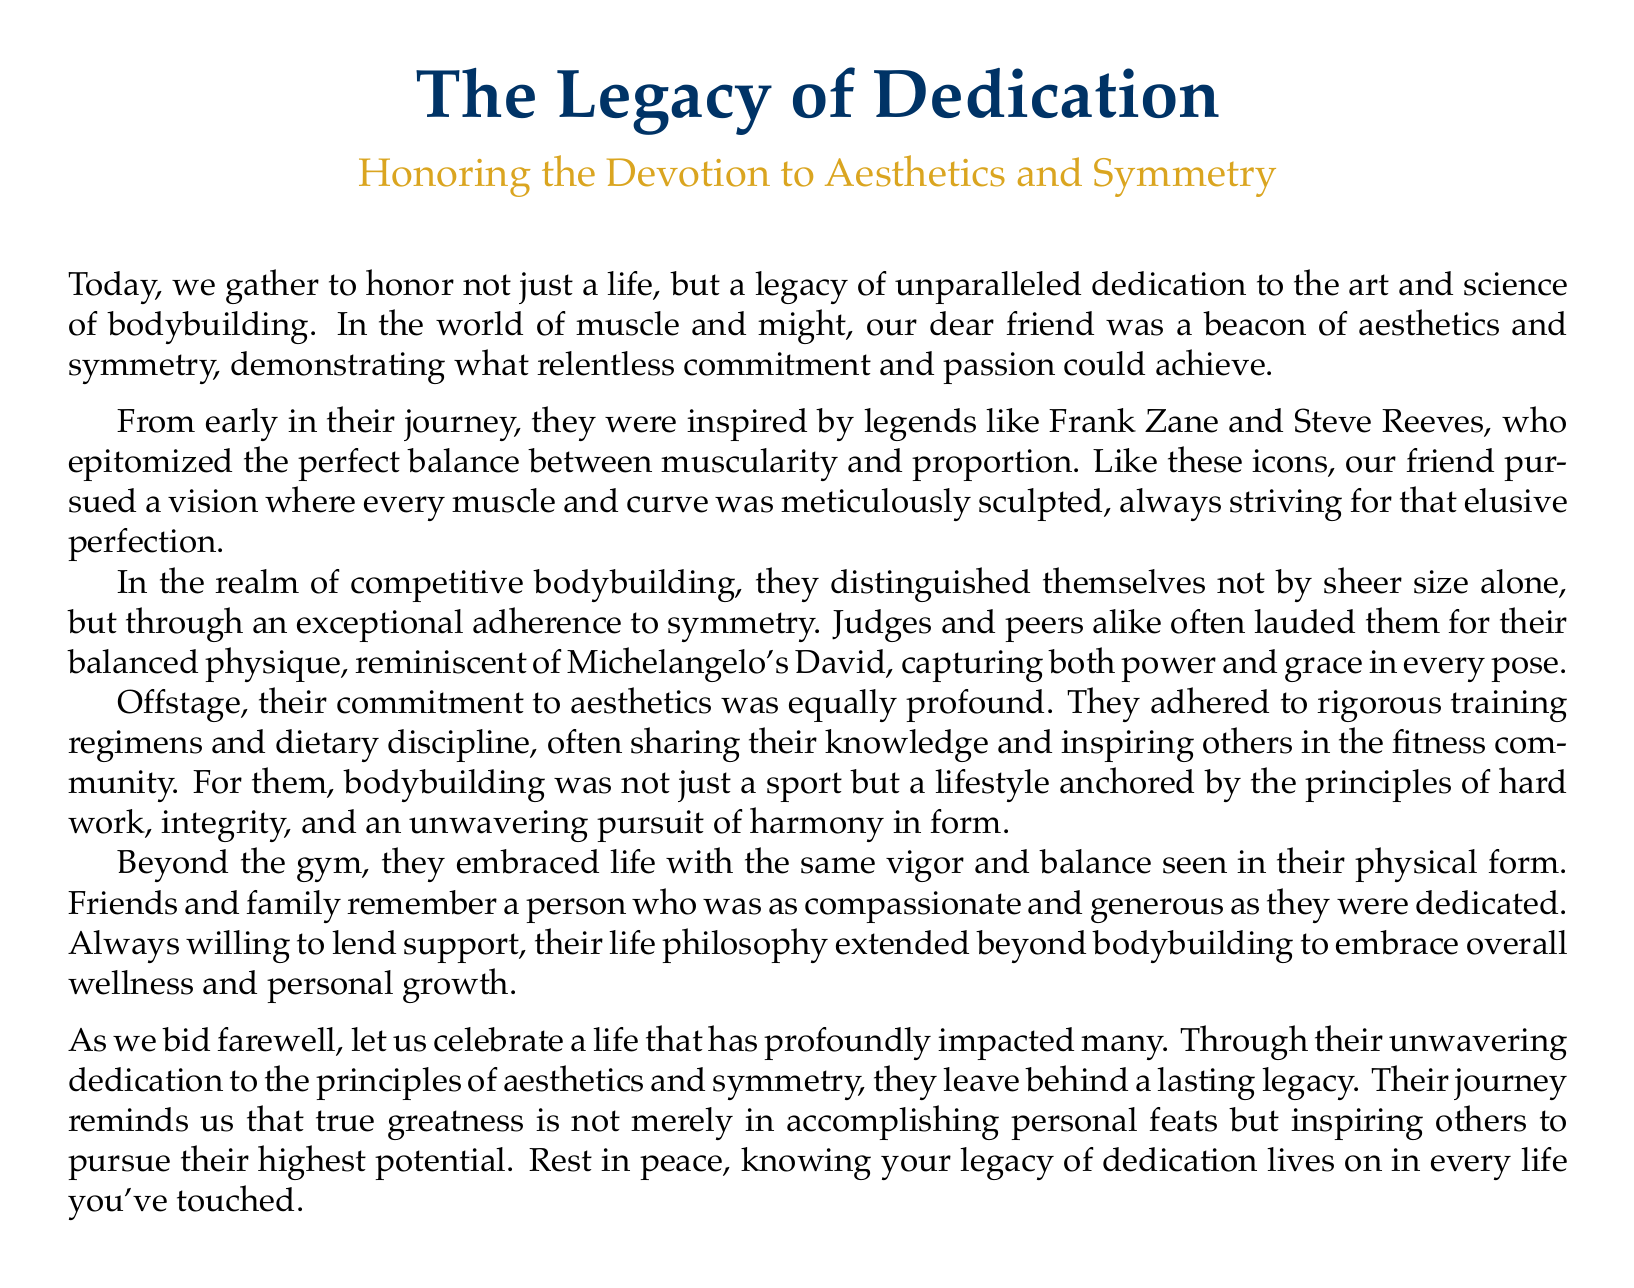What is the title of the document? The title is prominently displayed at the beginning of the document and reads "The Legacy of Dedication."
Answer: The Legacy of Dedication What is the subtitle of the document? The subtitle is also provided and reflects the theme, which is "Honoring the Devotion to Aesthetics and Symmetry."
Answer: Honoring the Devotion to Aesthetics and Symmetry Who were the inspirational figures mentioned? The document references two iconic figures who inspired the subject, which are Frank Zane and Steve Reeves.
Answer: Frank Zane and Steve Reeves What principle did the subject adhere to according to the document? The document indicates that the subject adhered to the principle of symmetry in bodybuilding.
Answer: Symmetry How did friends and family remember the subject? The document states that friends and family remember the subject as compassionate and generous.
Answer: Compassionate and generous What did the subject's philosophy extend to beyond bodybuilding? The document notes that the subject's life philosophy extended to overall wellness and personal growth.
Answer: Overall wellness and personal growth What did the legacy of the subject remind others about greatness? The document highlights that the legacy reminds us that true greatness is about inspiring others to pursue their highest potential.
Answer: Inspiring others to pursue their highest potential What type of competitions did the subject participate in? The document refers to the subject participating in competitive bodybuilding.
Answer: Competitive bodybuilding How is the subject described in relation to Michelangelo's work? The subject is compared to Michelangelo's David, emphasizing their balanced physique.
Answer: Michelangelo's David 